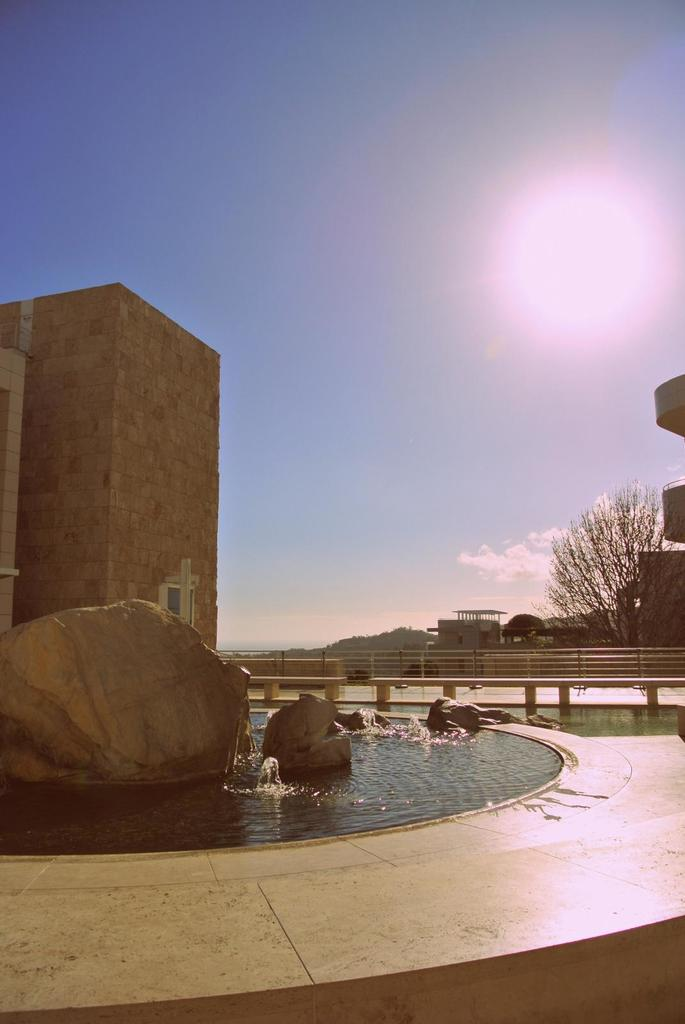What type of structures can be seen in the image? There are buildings in the image. What natural elements are present in the image? There are trees and water in the image. What man-made feature is visible in the image? There is fencing in the image. What geological feature can be seen in the image? There is a rock in the image. What is the color of the sky in the image? The sky is blue and white in color. How many tomatoes are growing on the rock in the image? There are no tomatoes present in the image; it features a rock without any plants. What type of camera can be seen in the image? There is no camera visible in the image. 